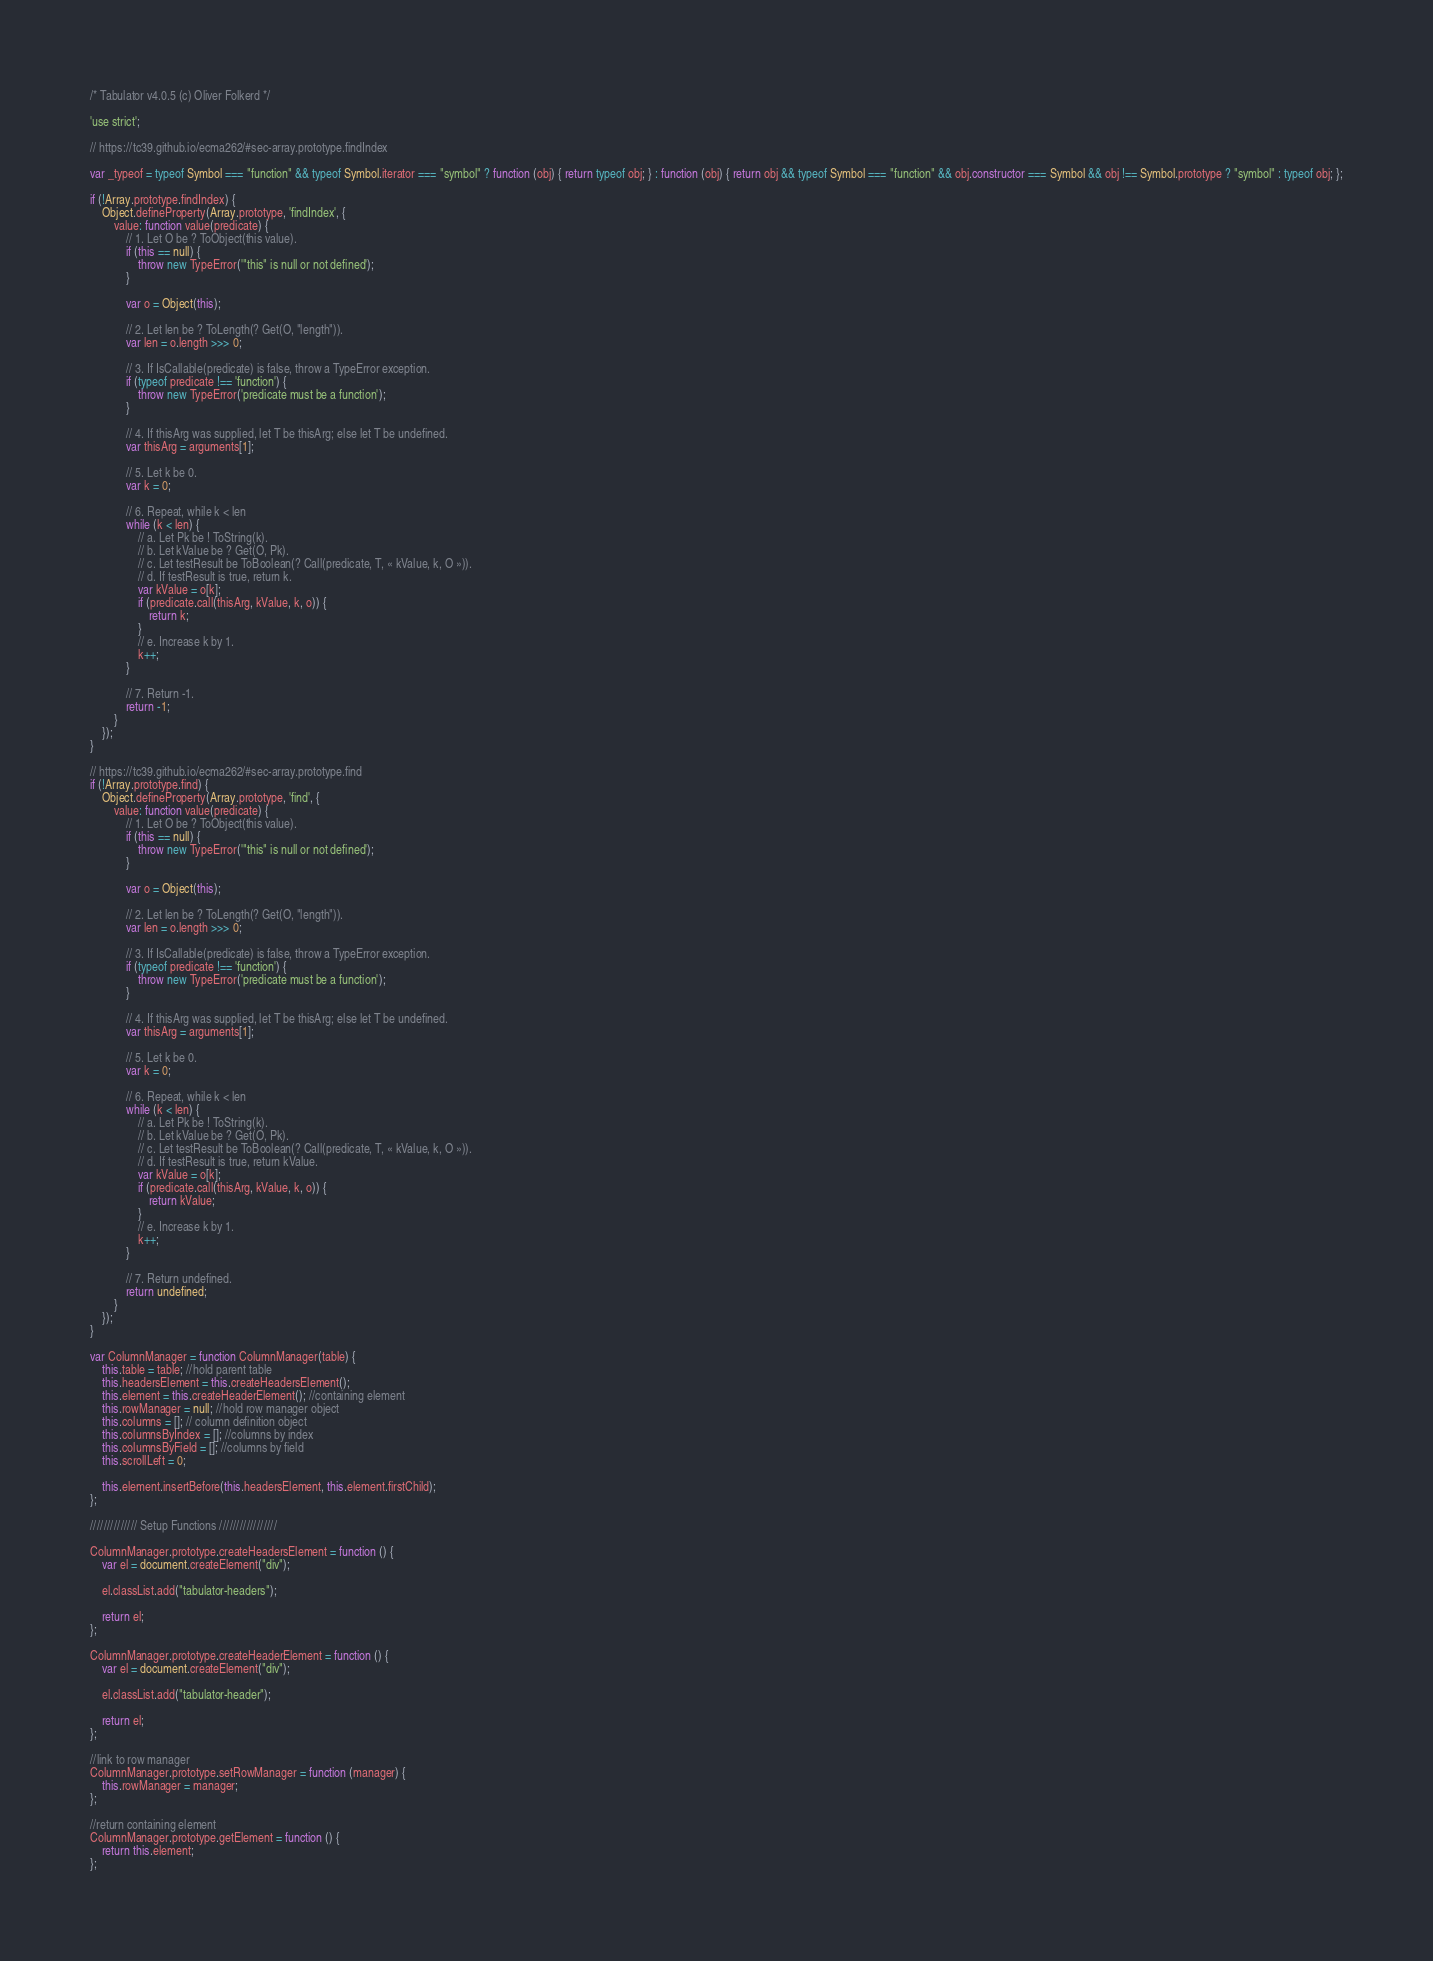<code> <loc_0><loc_0><loc_500><loc_500><_JavaScript_>/* Tabulator v4.0.5 (c) Oliver Folkerd */

'use strict';

// https://tc39.github.io/ecma262/#sec-array.prototype.findIndex

var _typeof = typeof Symbol === "function" && typeof Symbol.iterator === "symbol" ? function (obj) { return typeof obj; } : function (obj) { return obj && typeof Symbol === "function" && obj.constructor === Symbol && obj !== Symbol.prototype ? "symbol" : typeof obj; };

if (!Array.prototype.findIndex) {
	Object.defineProperty(Array.prototype, 'findIndex', {
		value: function value(predicate) {
			// 1. Let O be ? ToObject(this value).
			if (this == null) {
				throw new TypeError('"this" is null or not defined');
			}

			var o = Object(this);

			// 2. Let len be ? ToLength(? Get(O, "length")).
			var len = o.length >>> 0;

			// 3. If IsCallable(predicate) is false, throw a TypeError exception.
			if (typeof predicate !== 'function') {
				throw new TypeError('predicate must be a function');
			}

			// 4. If thisArg was supplied, let T be thisArg; else let T be undefined.
			var thisArg = arguments[1];

			// 5. Let k be 0.
			var k = 0;

			// 6. Repeat, while k < len
			while (k < len) {
				// a. Let Pk be ! ToString(k).
				// b. Let kValue be ? Get(O, Pk).
				// c. Let testResult be ToBoolean(? Call(predicate, T, « kValue, k, O »)).
				// d. If testResult is true, return k.
				var kValue = o[k];
				if (predicate.call(thisArg, kValue, k, o)) {
					return k;
				}
				// e. Increase k by 1.
				k++;
			}

			// 7. Return -1.
			return -1;
		}
	});
}

// https://tc39.github.io/ecma262/#sec-array.prototype.find
if (!Array.prototype.find) {
	Object.defineProperty(Array.prototype, 'find', {
		value: function value(predicate) {
			// 1. Let O be ? ToObject(this value).
			if (this == null) {
				throw new TypeError('"this" is null or not defined');
			}

			var o = Object(this);

			// 2. Let len be ? ToLength(? Get(O, "length")).
			var len = o.length >>> 0;

			// 3. If IsCallable(predicate) is false, throw a TypeError exception.
			if (typeof predicate !== 'function') {
				throw new TypeError('predicate must be a function');
			}

			// 4. If thisArg was supplied, let T be thisArg; else let T be undefined.
			var thisArg = arguments[1];

			// 5. Let k be 0.
			var k = 0;

			// 6. Repeat, while k < len
			while (k < len) {
				// a. Let Pk be ! ToString(k).
				// b. Let kValue be ? Get(O, Pk).
				// c. Let testResult be ToBoolean(? Call(predicate, T, « kValue, k, O »)).
				// d. If testResult is true, return kValue.
				var kValue = o[k];
				if (predicate.call(thisArg, kValue, k, o)) {
					return kValue;
				}
				// e. Increase k by 1.
				k++;
			}

			// 7. Return undefined.
			return undefined;
		}
	});
}

var ColumnManager = function ColumnManager(table) {
	this.table = table; //hold parent table
	this.headersElement = this.createHeadersElement();
	this.element = this.createHeaderElement(); //containing element
	this.rowManager = null; //hold row manager object
	this.columns = []; // column definition object
	this.columnsByIndex = []; //columns by index
	this.columnsByField = []; //columns by field
	this.scrollLeft = 0;

	this.element.insertBefore(this.headersElement, this.element.firstChild);
};

////////////// Setup Functions /////////////////

ColumnManager.prototype.createHeadersElement = function () {
	var el = document.createElement("div");

	el.classList.add("tabulator-headers");

	return el;
};

ColumnManager.prototype.createHeaderElement = function () {
	var el = document.createElement("div");

	el.classList.add("tabulator-header");

	return el;
};

//link to row manager
ColumnManager.prototype.setRowManager = function (manager) {
	this.rowManager = manager;
};

//return containing element
ColumnManager.prototype.getElement = function () {
	return this.element;
};
</code> 